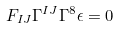Convert formula to latex. <formula><loc_0><loc_0><loc_500><loc_500>F _ { I J } \Gamma ^ { I J } \Gamma ^ { 8 } \epsilon = 0</formula> 